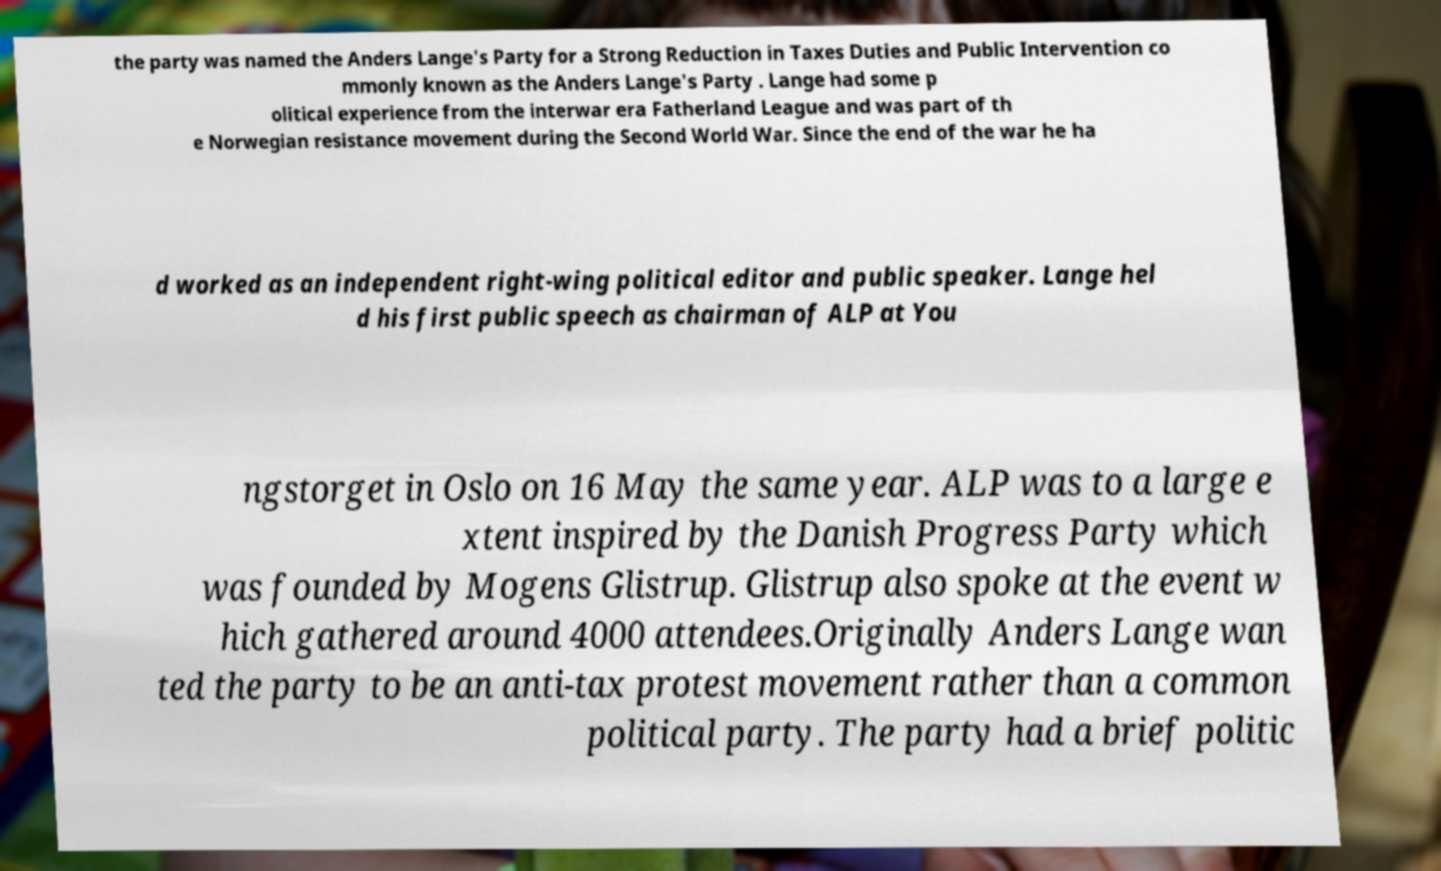Could you extract and type out the text from this image? the party was named the Anders Lange's Party for a Strong Reduction in Taxes Duties and Public Intervention co mmonly known as the Anders Lange's Party . Lange had some p olitical experience from the interwar era Fatherland League and was part of th e Norwegian resistance movement during the Second World War. Since the end of the war he ha d worked as an independent right-wing political editor and public speaker. Lange hel d his first public speech as chairman of ALP at You ngstorget in Oslo on 16 May the same year. ALP was to a large e xtent inspired by the Danish Progress Party which was founded by Mogens Glistrup. Glistrup also spoke at the event w hich gathered around 4000 attendees.Originally Anders Lange wan ted the party to be an anti-tax protest movement rather than a common political party. The party had a brief politic 